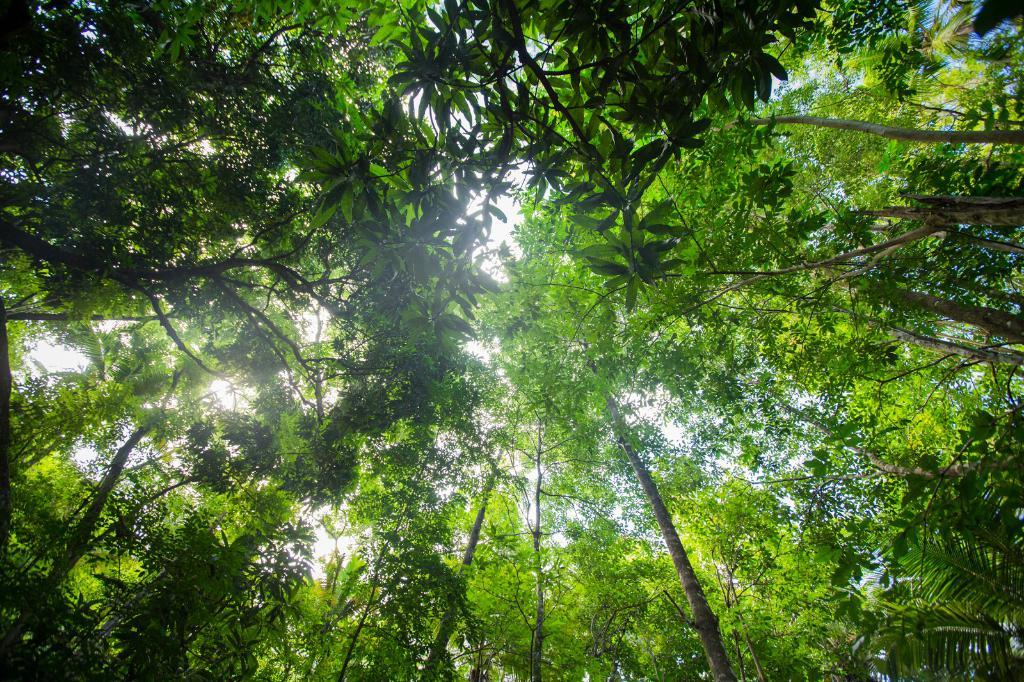Where was the image taken from? The image is taken from outside the city. What type of vegetation can be seen in the image? There are trees in the image. What type of insect can be seen on the plate in the image? There is no plate or insect present in the image. 